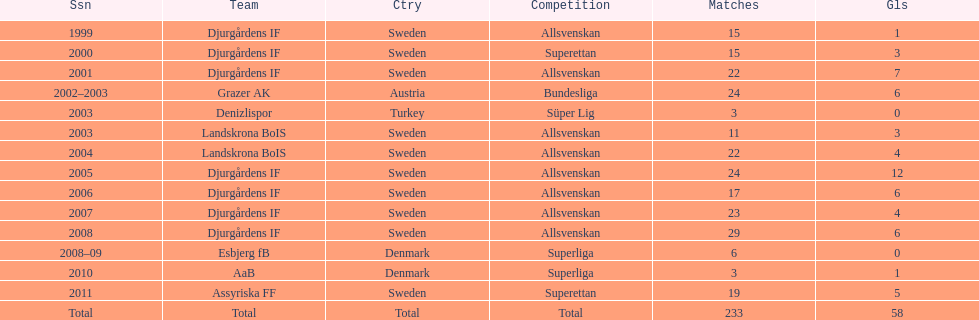What was the number of goals he scored in 2005? 12. 